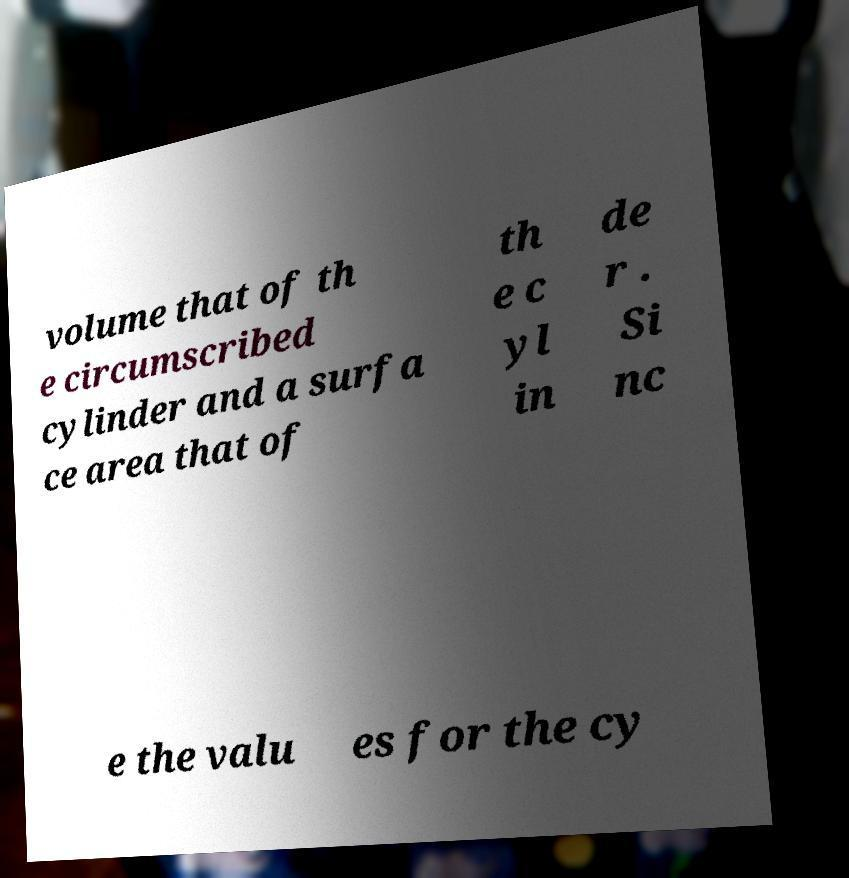Can you read and provide the text displayed in the image?This photo seems to have some interesting text. Can you extract and type it out for me? volume that of th e circumscribed cylinder and a surfa ce area that of th e c yl in de r . Si nc e the valu es for the cy 